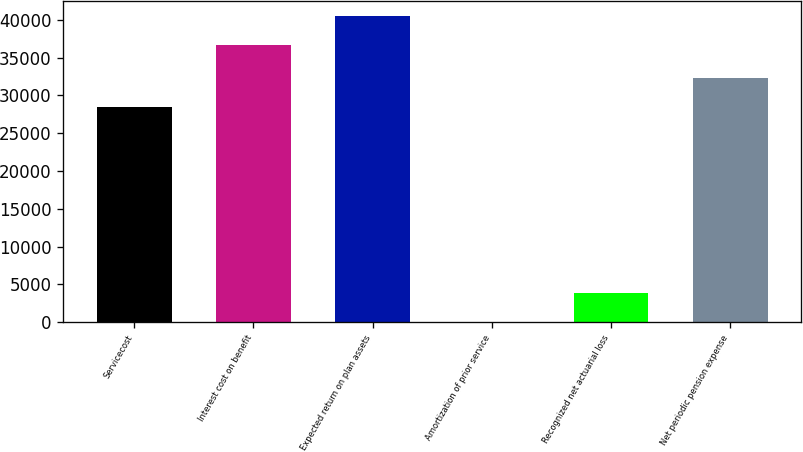<chart> <loc_0><loc_0><loc_500><loc_500><bar_chart><fcel>Servicecost<fcel>Interest cost on benefit<fcel>Expected return on plan assets<fcel>Amortization of prior service<fcel>Recognized net actuarial loss<fcel>Net periodic pension expense<nl><fcel>28505<fcel>36704<fcel>40462.5<fcel>57<fcel>3815.5<fcel>32263.5<nl></chart> 